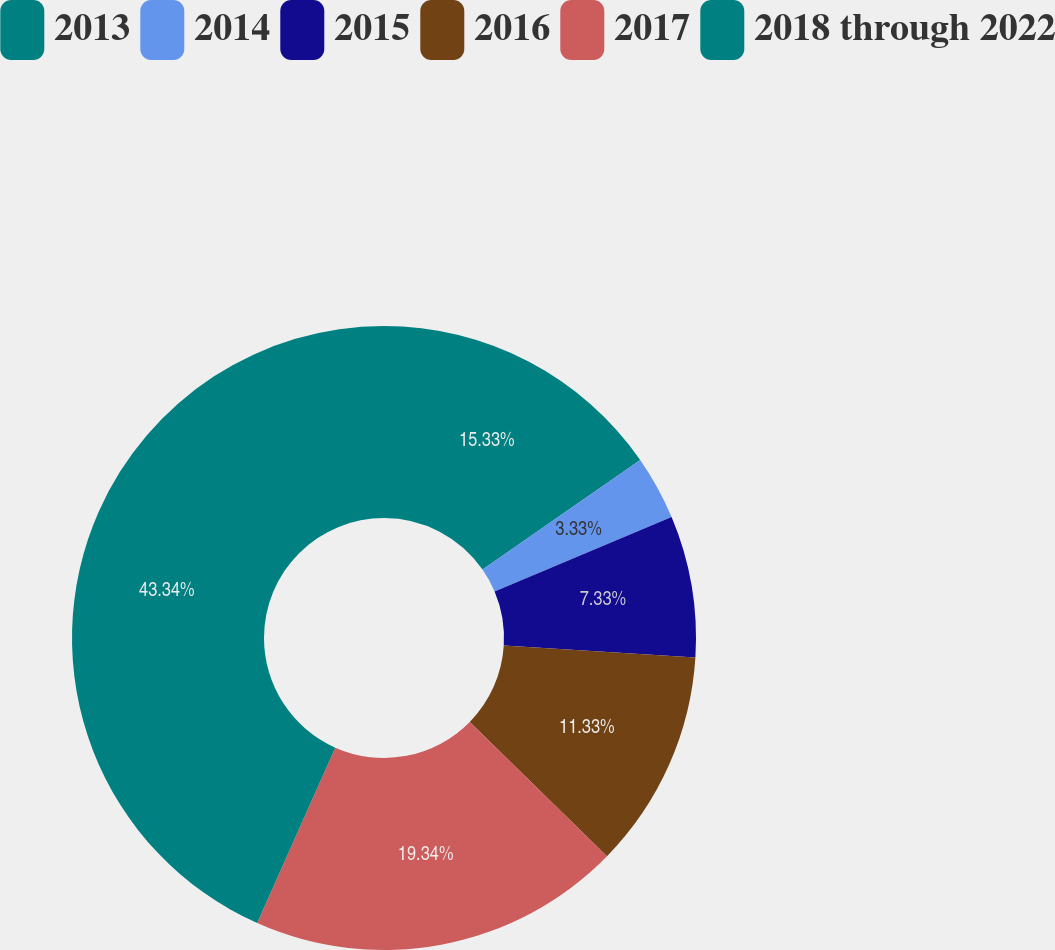Convert chart to OTSL. <chart><loc_0><loc_0><loc_500><loc_500><pie_chart><fcel>2013<fcel>2014<fcel>2015<fcel>2016<fcel>2017<fcel>2018 through 2022<nl><fcel>15.33%<fcel>3.33%<fcel>7.33%<fcel>11.33%<fcel>19.33%<fcel>43.33%<nl></chart> 